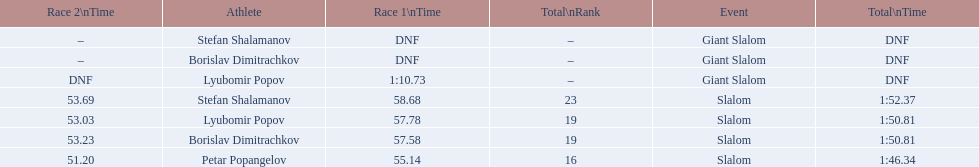What is the number of athletes to finish race one in the giant slalom? 1. 